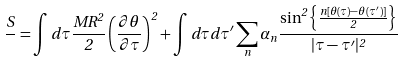Convert formula to latex. <formula><loc_0><loc_0><loc_500><loc_500>\frac { S } { } = \int d \tau \frac { M R ^ { 2 } } { 2 } \left ( \frac { \partial \theta } { \partial \tau } \right ) ^ { 2 } + \int d \tau d \tau ^ { \prime } \sum _ { n } \alpha _ { n } \frac { \sin ^ { 2 } \left \{ \frac { n [ \theta ( \tau ) - \theta ( \tau ^ { \prime } ) ] } { 2 } \right \} } { | \tau - \tau ^ { \prime } | ^ { 2 } }</formula> 